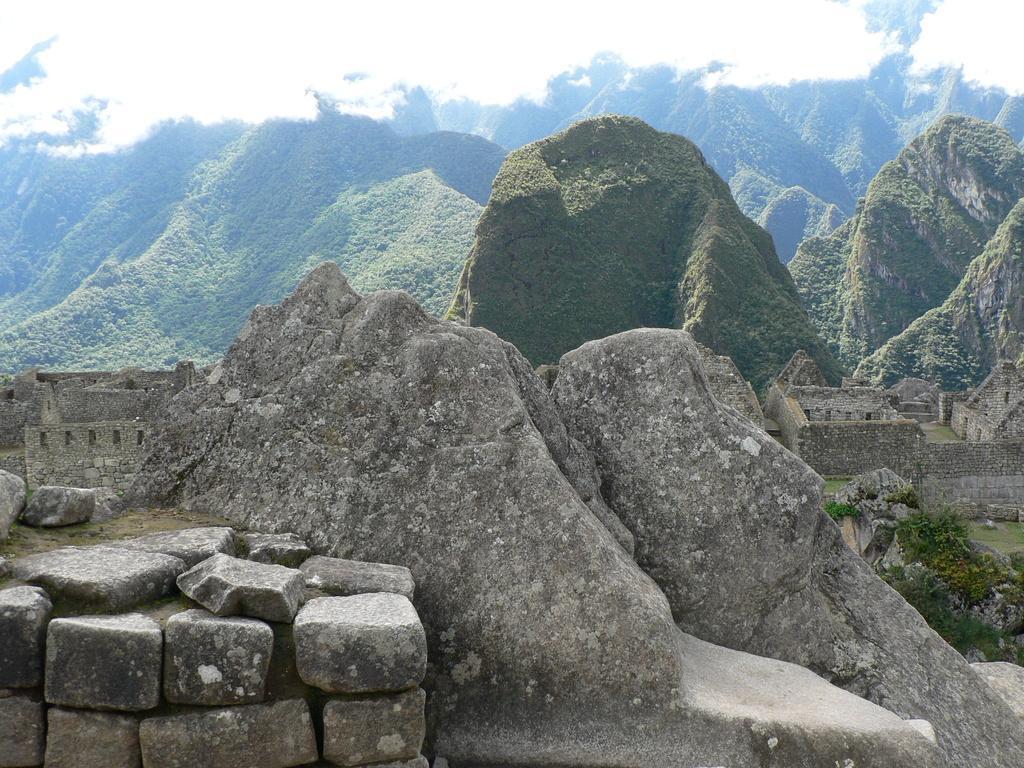Please provide a concise description of this image. In the picture we can see some stones and in the background of the picture there are some mountains and clear sky. 